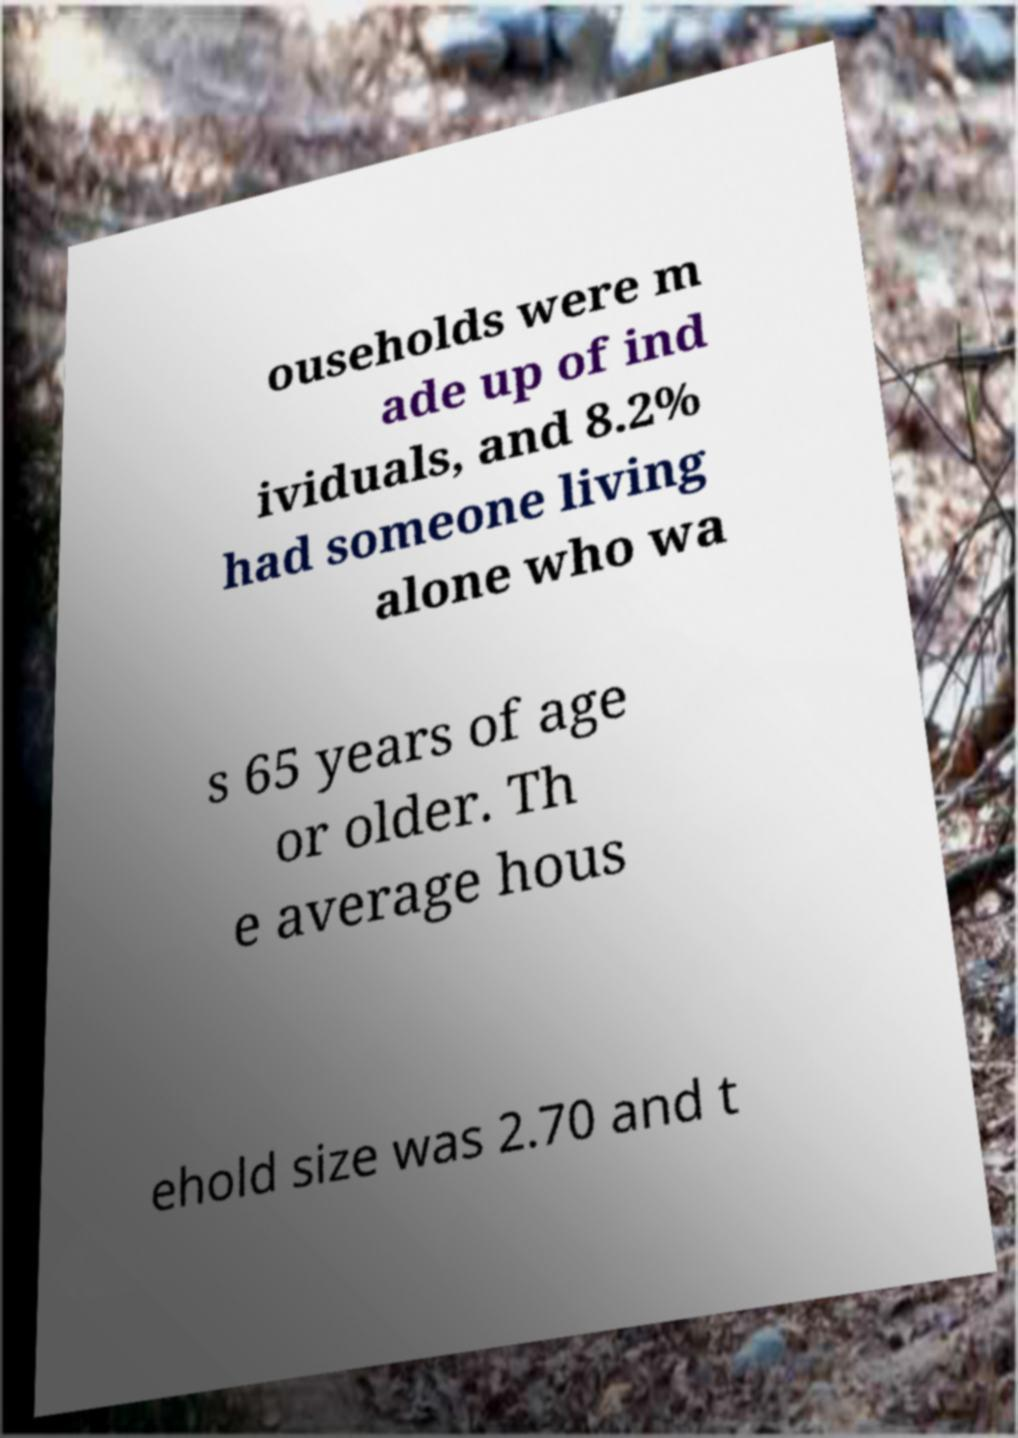I need the written content from this picture converted into text. Can you do that? ouseholds were m ade up of ind ividuals, and 8.2% had someone living alone who wa s 65 years of age or older. Th e average hous ehold size was 2.70 and t 